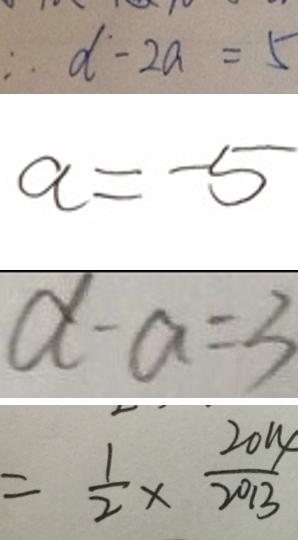Convert formula to latex. <formula><loc_0><loc_0><loc_500><loc_500>\therefore d - 2 a = 5 
 a = - 5 
 d - a = 3 
 = \frac { 1 } { 2 } \times \frac { 2 0 1 4 } { 2 0 1 3 }</formula> 